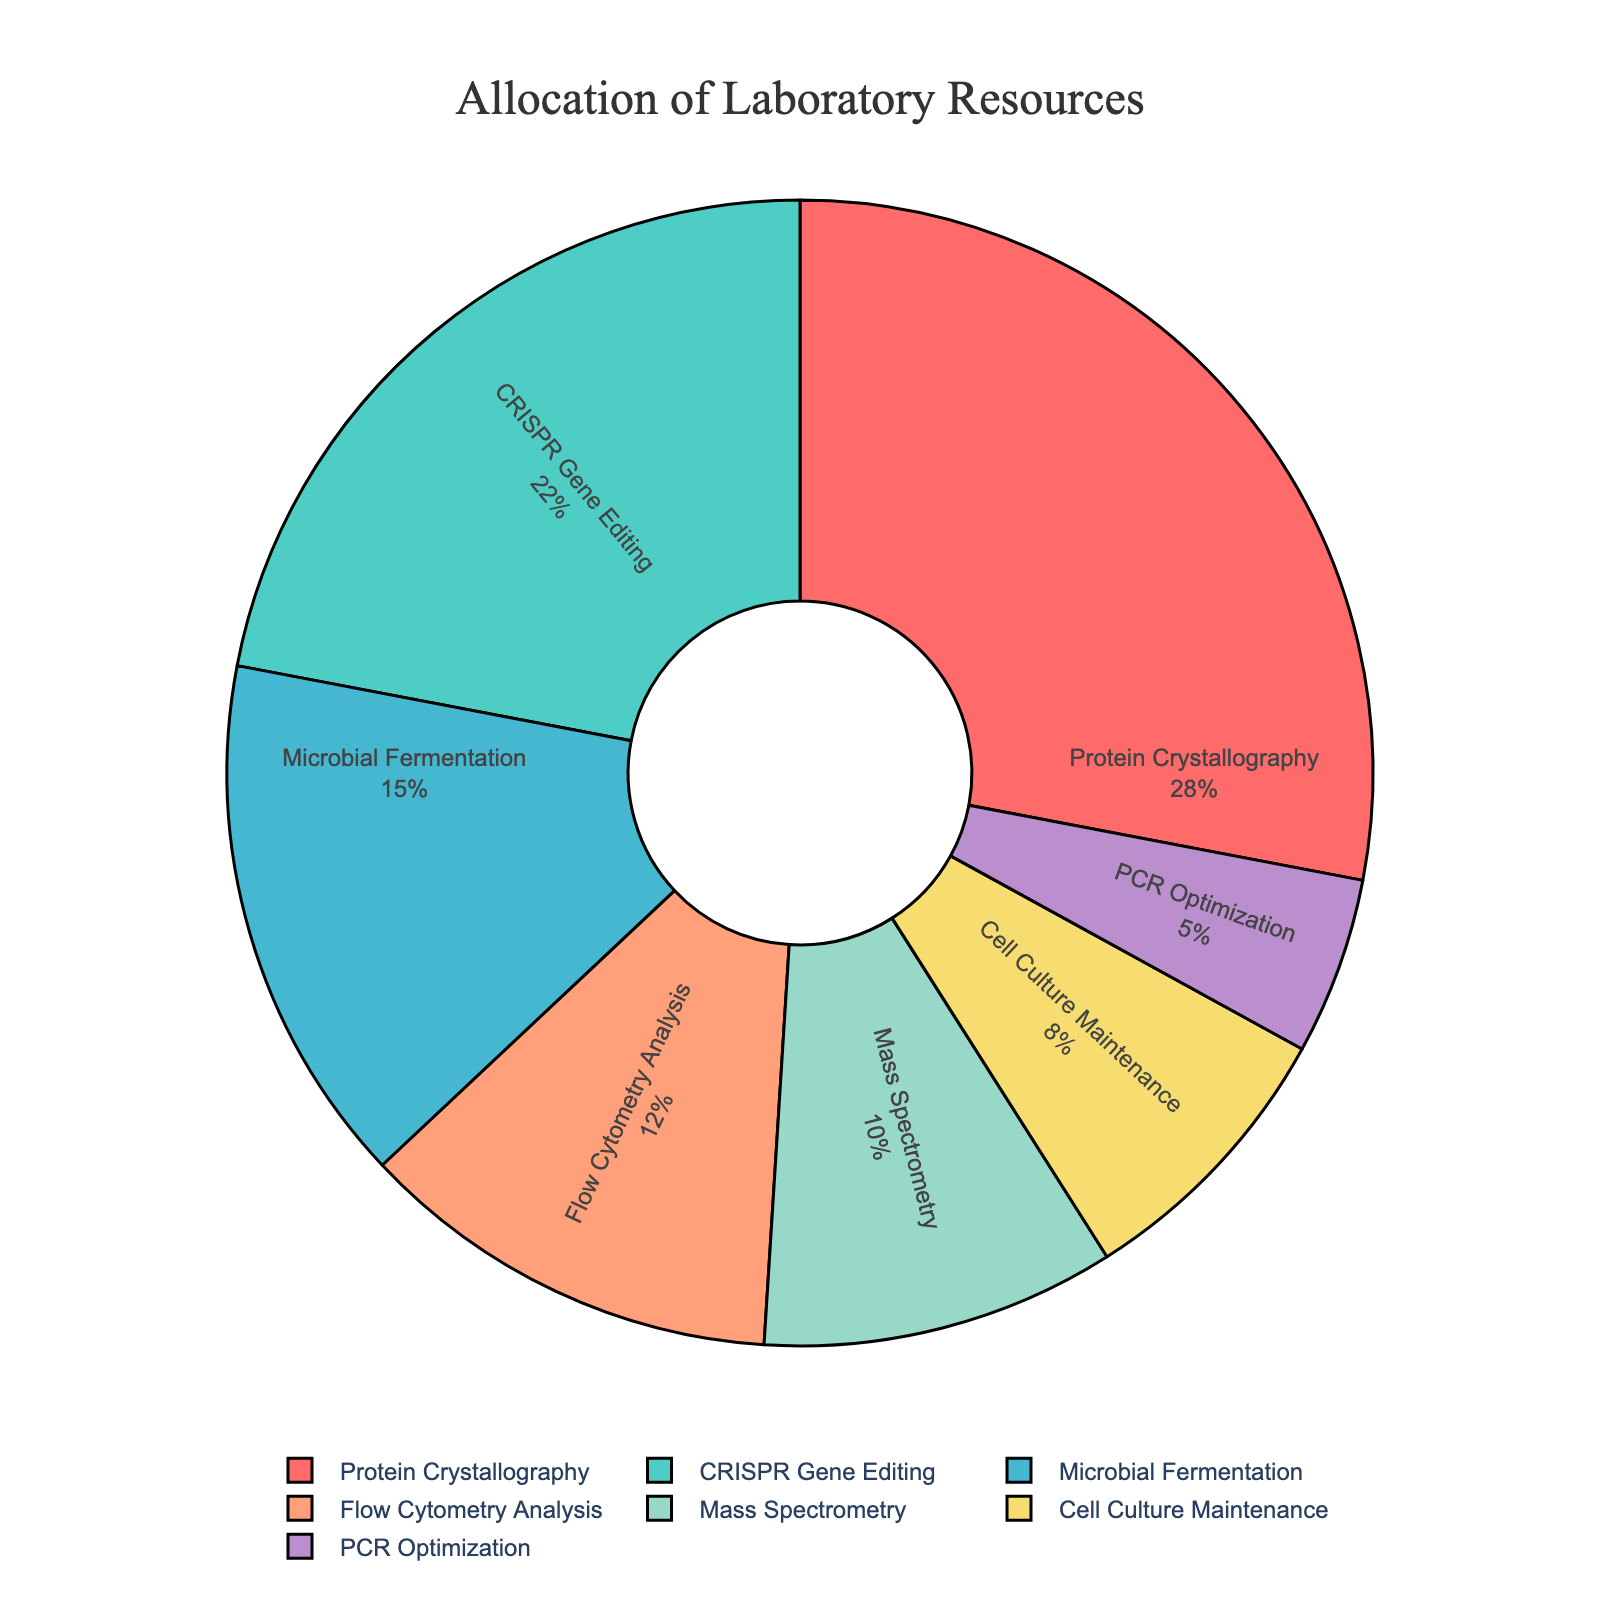Which research project has the highest allocation of resources? Look at the pie chart and identify the segment with the largest size. The label inside the largest segment reads "Protein Crystallography".
Answer: Protein Crystallography Which research project uses the least amount of resources? Look at the pie chart and identify the smallest segment. The label inside the smallest segment reads "PCR Optimization".
Answer: PCR Optimization What is the total percentage of resources allocated to CRISPR Gene Editing and Microbial Fermentation combined? Identify the segments for CRISPR Gene Editing and Microbial Fermentation. CRISPR Gene Editing is 22% and Microbial Fermentation is 15%. Adding these percentages together, 22% + 15% = 37%.
Answer: 37% How does the allocation for Flow Cytometry Analysis compare to Mass Spectrometry? Identify the segments for Flow Cytometry Analysis and Mass Spectrometry. Flow Cytometry Analysis is 12%, and Mass Spectrometry is 10%. Flow Cytometry Analysis is greater than Mass Spectrometry by 2%.
Answer: Flow Cytometry Analysis is greater by 2% Which segment is represented by the color green in the pie chart? Look at the pie chart and identify the segment colored in green. It is labeled "CRISPR Gene Editing".
Answer: CRISPR Gene Editing What percentage of resources is allocated to projects other than Cell Culture Maintenance and PCR Optimization? The total allocation is 100%. Cell Culture Maintenance is 8% and PCR Optimization is 5%. Subtract their sum from 100%: 100% - (8% + 5%) = 87%.
Answer: 87% What is the average allocation of resources for the top three projects? Identify the top three projects by their allocation percentages: Protein Crystallography (28%), CRISPR Gene Editing (22%), Microbial Fermentation (15%). Sum these percentages: 28% + 22% + 15% = 65%. Divide by 3 to find the average: 65% / 3 ≈ 21.67%.
Answer: 21.67% If resources for CRISPR Gene Editing were increased by 5 percentage points, what would the new allocation be? CRISPR Gene Editing currently has 22%. Adding 5 percentage points: 22% + 5% = 27%.
Answer: 27% 